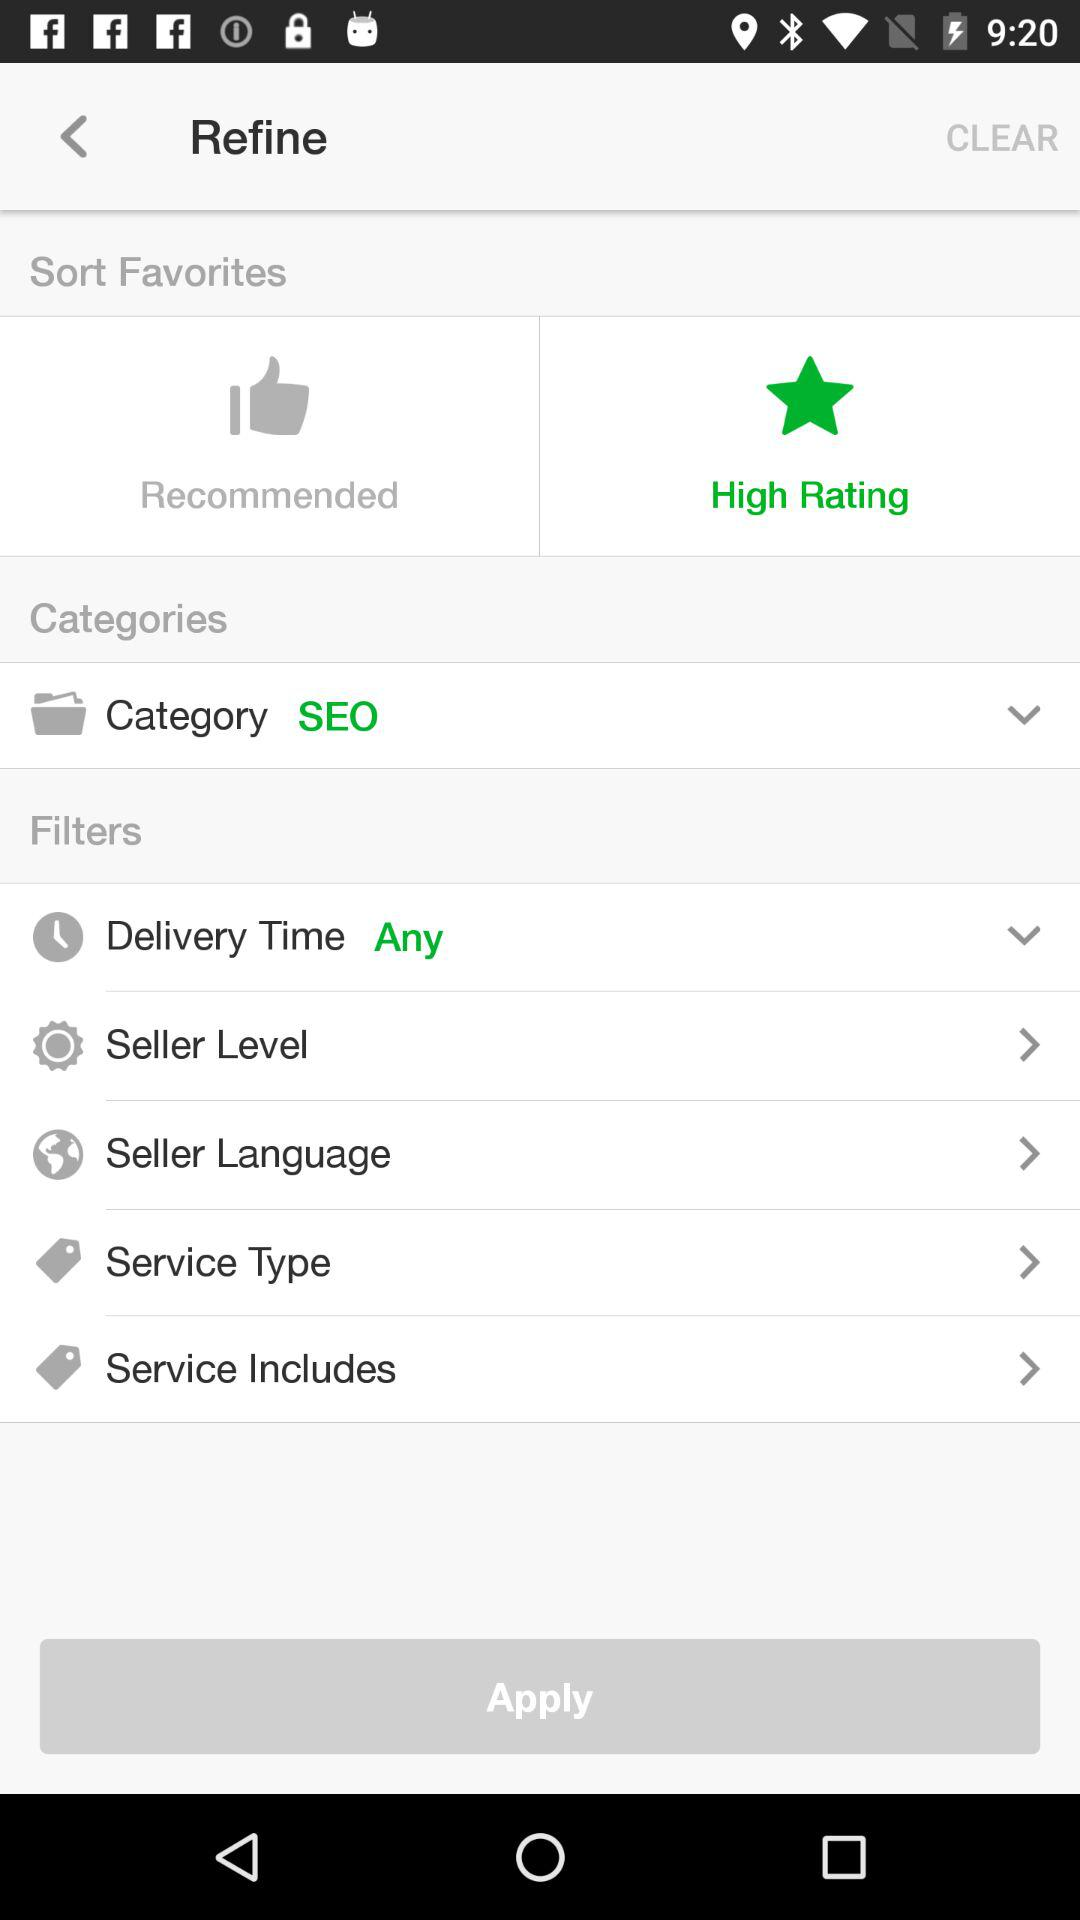Which tab is selected? The selected tab is "High Rating". 